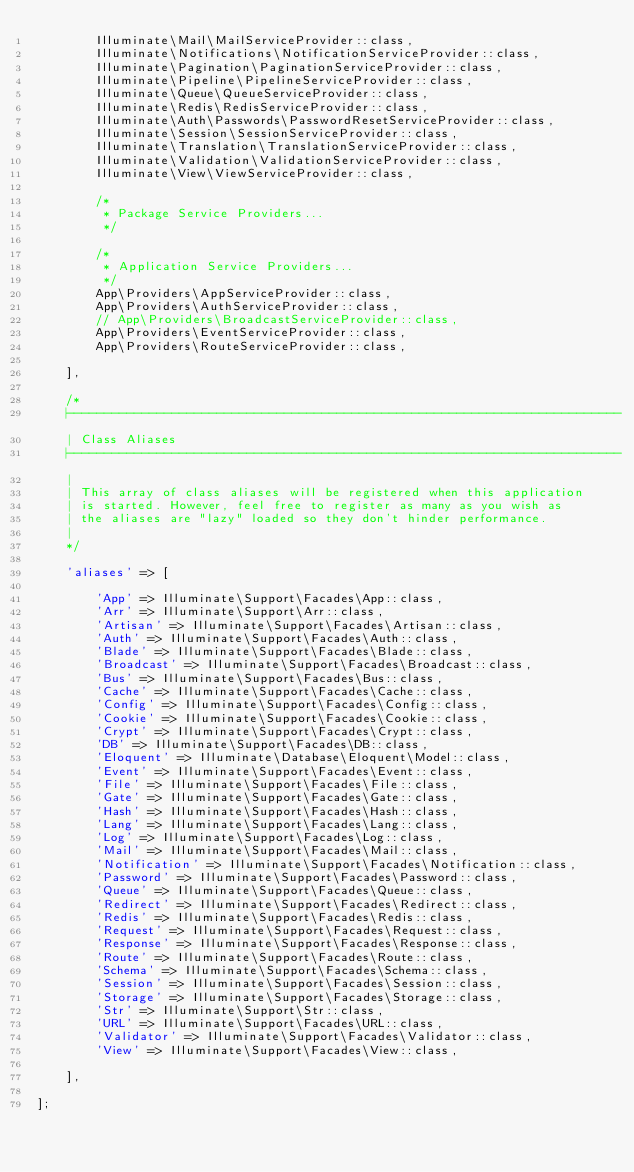Convert code to text. <code><loc_0><loc_0><loc_500><loc_500><_PHP_>        Illuminate\Mail\MailServiceProvider::class,
        Illuminate\Notifications\NotificationServiceProvider::class,
        Illuminate\Pagination\PaginationServiceProvider::class,
        Illuminate\Pipeline\PipelineServiceProvider::class,
        Illuminate\Queue\QueueServiceProvider::class,
        Illuminate\Redis\RedisServiceProvider::class,
        Illuminate\Auth\Passwords\PasswordResetServiceProvider::class,
        Illuminate\Session\SessionServiceProvider::class,
        Illuminate\Translation\TranslationServiceProvider::class,
        Illuminate\Validation\ValidationServiceProvider::class,
        Illuminate\View\ViewServiceProvider::class,

        /*
         * Package Service Providers...
         */

        /*
         * Application Service Providers...
         */
        App\Providers\AppServiceProvider::class,
        App\Providers\AuthServiceProvider::class,
        // App\Providers\BroadcastServiceProvider::class,
        App\Providers\EventServiceProvider::class,
        App\Providers\RouteServiceProvider::class,

    ],

    /*
    |--------------------------------------------------------------------------
    | Class Aliases
    |--------------------------------------------------------------------------
    |
    | This array of class aliases will be registered when this application
    | is started. However, feel free to register as many as you wish as
    | the aliases are "lazy" loaded so they don't hinder performance.
    |
    */

    'aliases' => [

        'App' => Illuminate\Support\Facades\App::class,
        'Arr' => Illuminate\Support\Arr::class,
        'Artisan' => Illuminate\Support\Facades\Artisan::class,
        'Auth' => Illuminate\Support\Facades\Auth::class,
        'Blade' => Illuminate\Support\Facades\Blade::class,
        'Broadcast' => Illuminate\Support\Facades\Broadcast::class,
        'Bus' => Illuminate\Support\Facades\Bus::class,
        'Cache' => Illuminate\Support\Facades\Cache::class,
        'Config' => Illuminate\Support\Facades\Config::class,
        'Cookie' => Illuminate\Support\Facades\Cookie::class,
        'Crypt' => Illuminate\Support\Facades\Crypt::class,
        'DB' => Illuminate\Support\Facades\DB::class,
        'Eloquent' => Illuminate\Database\Eloquent\Model::class,
        'Event' => Illuminate\Support\Facades\Event::class,
        'File' => Illuminate\Support\Facades\File::class,
        'Gate' => Illuminate\Support\Facades\Gate::class,
        'Hash' => Illuminate\Support\Facades\Hash::class,
        'Lang' => Illuminate\Support\Facades\Lang::class,
        'Log' => Illuminate\Support\Facades\Log::class,
        'Mail' => Illuminate\Support\Facades\Mail::class,
        'Notification' => Illuminate\Support\Facades\Notification::class,
        'Password' => Illuminate\Support\Facades\Password::class,
        'Queue' => Illuminate\Support\Facades\Queue::class,
        'Redirect' => Illuminate\Support\Facades\Redirect::class,
        'Redis' => Illuminate\Support\Facades\Redis::class,
        'Request' => Illuminate\Support\Facades\Request::class,
        'Response' => Illuminate\Support\Facades\Response::class,
        'Route' => Illuminate\Support\Facades\Route::class,
        'Schema' => Illuminate\Support\Facades\Schema::class,
        'Session' => Illuminate\Support\Facades\Session::class,
        'Storage' => Illuminate\Support\Facades\Storage::class,
        'Str' => Illuminate\Support\Str::class,
        'URL' => Illuminate\Support\Facades\URL::class,
        'Validator' => Illuminate\Support\Facades\Validator::class,
        'View' => Illuminate\Support\Facades\View::class,

    ],

];
</code> 